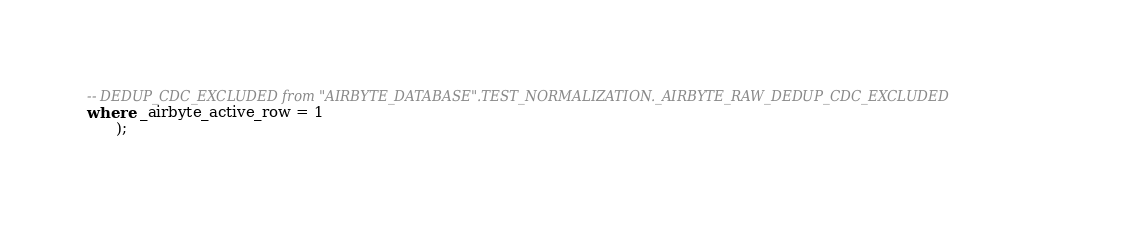<code> <loc_0><loc_0><loc_500><loc_500><_SQL_>-- DEDUP_CDC_EXCLUDED from "AIRBYTE_DATABASE".TEST_NORMALIZATION._AIRBYTE_RAW_DEDUP_CDC_EXCLUDED
where _airbyte_active_row = 1
      );
    </code> 